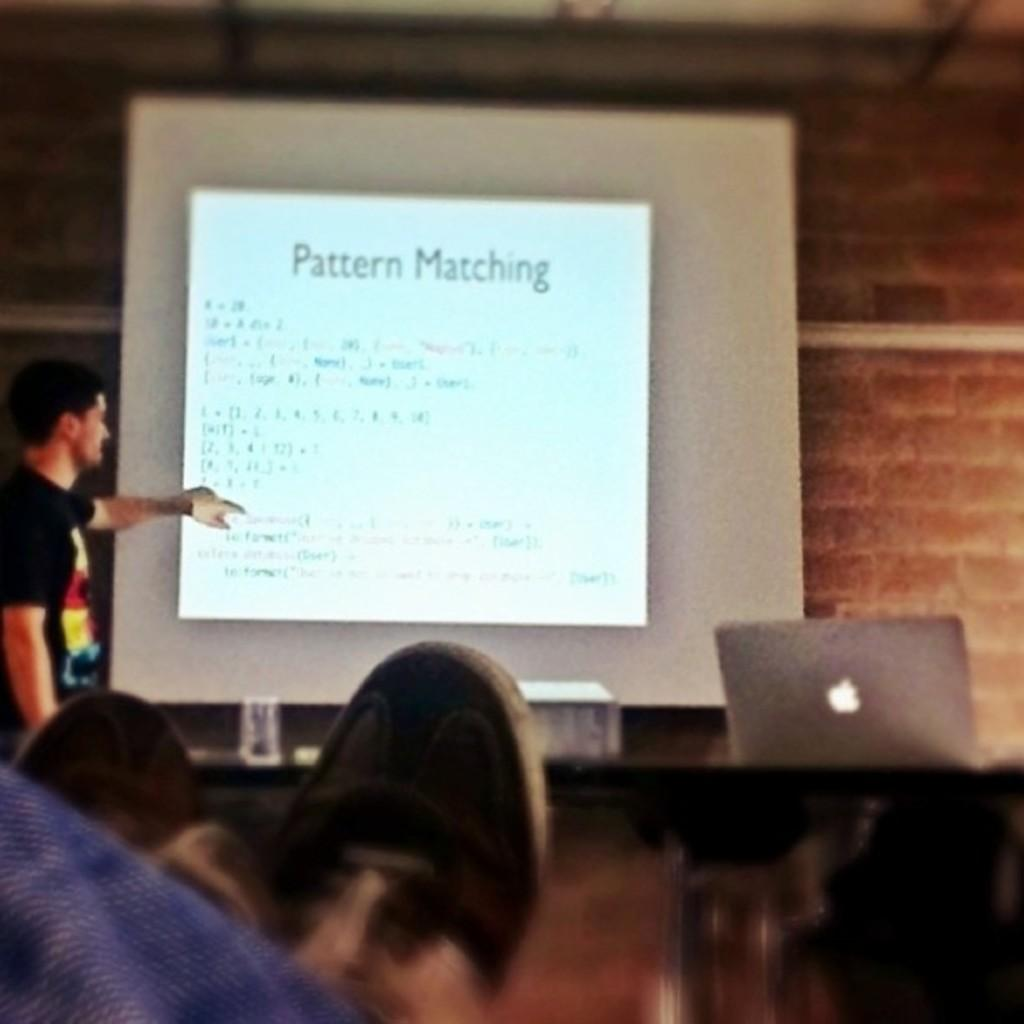Who or what is present in the image? There is a person in the image. What is the person doing or interacting with in the image? The person is at a screen. What device is visible at the bottom of the image? There is a laptop at the bottom of the image. What part of the person's body can be seen in the image? Human legs are visible in the image. What can be seen in the background of the image? There is a wall in the background of the image. What type of match is being played in the image? There is no match being played in the image; it features a person at a screen with a laptop and a wall in the background. How many roses are visible in the image? There are no roses present in the image. 